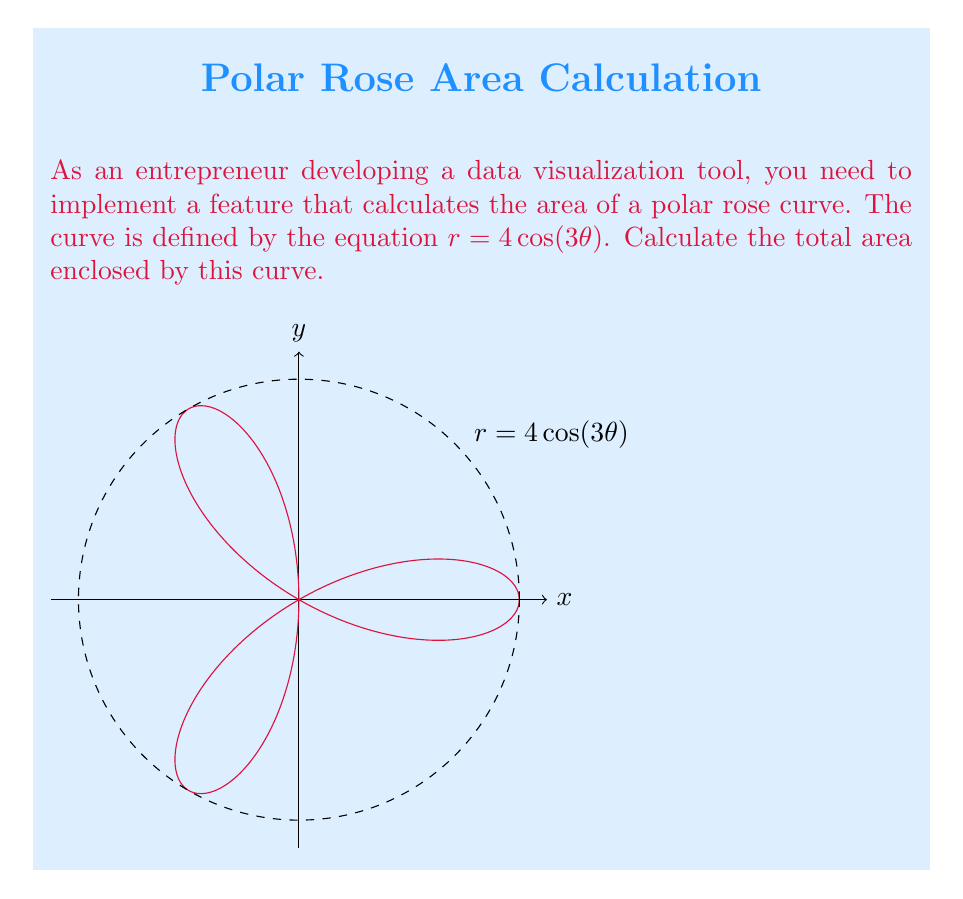Help me with this question. To calculate the area of a polar rose curve, we can use the formula:

$$A = \frac{1}{2} \int_{0}^{2\pi} r^2 d\theta$$

For our curve $r = 4\cos(3\theta)$, we need to follow these steps:

1) Square the radius function:
   $r^2 = (4\cos(3\theta))^2 = 16\cos^2(3\theta)$

2) Substitute this into the area formula:
   $$A = \frac{1}{2} \int_{0}^{2\pi} 16\cos^2(3\theta) d\theta$$

3) Use the trigonometric identity $\cos^2 x = \frac{1 + \cos(2x)}{2}$:
   $$A = \frac{1}{2} \int_{0}^{2\pi} 16 \cdot \frac{1 + \cos(6\theta)}{2} d\theta$$
   $$A = 4 \int_{0}^{2\pi} (1 + \cos(6\theta)) d\theta$$

4) Integrate:
   $$A = 4 [\theta + \frac{1}{6}\sin(6\theta)]_0^{2\pi}$$

5) Evaluate the definite integral:
   $$A = 4 [(2\pi + 0) - (0 + 0)] = 8\pi$$

Therefore, the total area enclosed by the polar rose curve is $8\pi$ square units.
Answer: $8\pi$ square units 